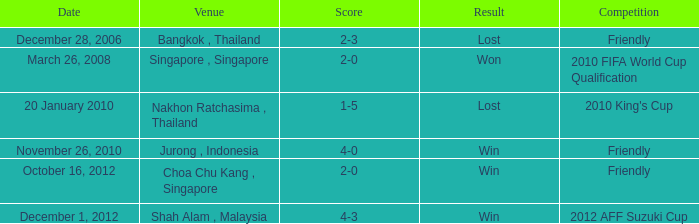Name the date for score of 1-5 20 January 2010. 